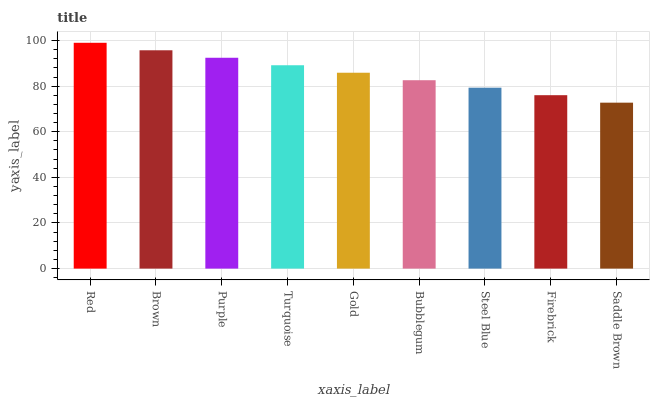Is Saddle Brown the minimum?
Answer yes or no. Yes. Is Red the maximum?
Answer yes or no. Yes. Is Brown the minimum?
Answer yes or no. No. Is Brown the maximum?
Answer yes or no. No. Is Red greater than Brown?
Answer yes or no. Yes. Is Brown less than Red?
Answer yes or no. Yes. Is Brown greater than Red?
Answer yes or no. No. Is Red less than Brown?
Answer yes or no. No. Is Gold the high median?
Answer yes or no. Yes. Is Gold the low median?
Answer yes or no. Yes. Is Steel Blue the high median?
Answer yes or no. No. Is Steel Blue the low median?
Answer yes or no. No. 